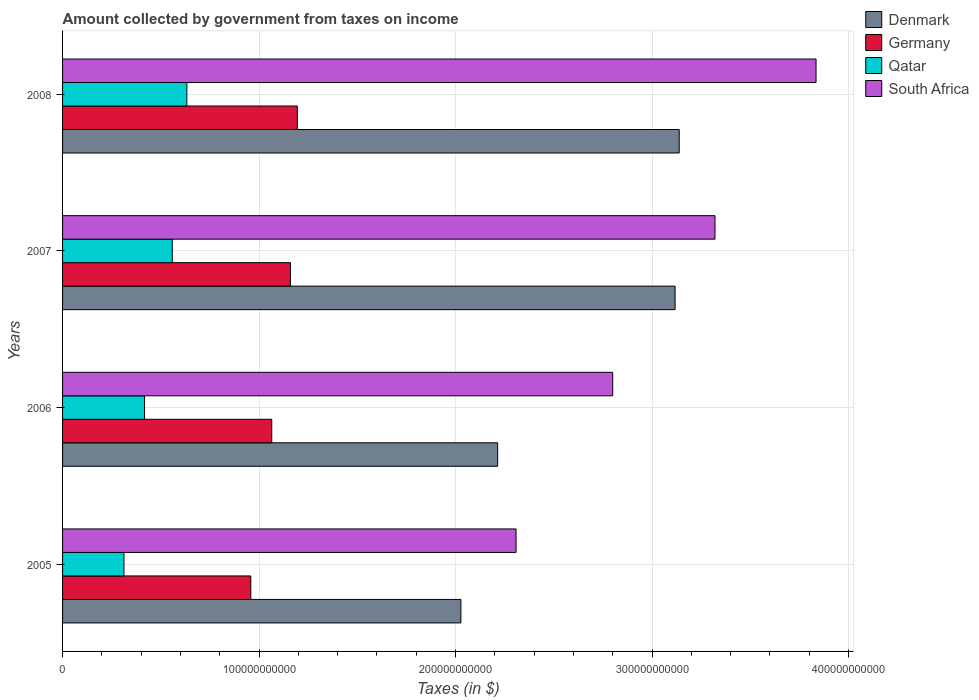How many different coloured bars are there?
Make the answer very short. 4. How many bars are there on the 3rd tick from the top?
Your answer should be very brief. 4. How many bars are there on the 2nd tick from the bottom?
Keep it short and to the point. 4. What is the label of the 1st group of bars from the top?
Offer a very short reply. 2008. In how many cases, is the number of bars for a given year not equal to the number of legend labels?
Offer a terse response. 0. What is the amount collected by government from taxes on income in Denmark in 2007?
Your answer should be very brief. 3.12e+11. Across all years, what is the maximum amount collected by government from taxes on income in Germany?
Provide a short and direct response. 1.19e+11. Across all years, what is the minimum amount collected by government from taxes on income in Denmark?
Your response must be concise. 2.03e+11. In which year was the amount collected by government from taxes on income in Germany maximum?
Offer a terse response. 2008. In which year was the amount collected by government from taxes on income in South Africa minimum?
Your response must be concise. 2005. What is the total amount collected by government from taxes on income in Germany in the graph?
Make the answer very short. 4.38e+11. What is the difference between the amount collected by government from taxes on income in South Africa in 2005 and that in 2006?
Provide a short and direct response. -4.92e+1. What is the difference between the amount collected by government from taxes on income in Germany in 2006 and the amount collected by government from taxes on income in Qatar in 2008?
Your answer should be very brief. 4.32e+1. What is the average amount collected by government from taxes on income in South Africa per year?
Give a very brief answer. 3.07e+11. In the year 2006, what is the difference between the amount collected by government from taxes on income in South Africa and amount collected by government from taxes on income in Germany?
Provide a succinct answer. 1.74e+11. In how many years, is the amount collected by government from taxes on income in South Africa greater than 240000000000 $?
Offer a terse response. 3. What is the ratio of the amount collected by government from taxes on income in Qatar in 2007 to that in 2008?
Your response must be concise. 0.88. Is the amount collected by government from taxes on income in Qatar in 2006 less than that in 2008?
Provide a short and direct response. Yes. Is the difference between the amount collected by government from taxes on income in South Africa in 2005 and 2008 greater than the difference between the amount collected by government from taxes on income in Germany in 2005 and 2008?
Your answer should be compact. No. What is the difference between the highest and the second highest amount collected by government from taxes on income in Germany?
Your response must be concise. 3.48e+09. What is the difference between the highest and the lowest amount collected by government from taxes on income in Denmark?
Your answer should be very brief. 1.11e+11. Is the sum of the amount collected by government from taxes on income in Germany in 2005 and 2007 greater than the maximum amount collected by government from taxes on income in Denmark across all years?
Offer a very short reply. No. What does the 2nd bar from the bottom in 2005 represents?
Your response must be concise. Germany. Are all the bars in the graph horizontal?
Provide a short and direct response. Yes. How many years are there in the graph?
Your response must be concise. 4. What is the difference between two consecutive major ticks on the X-axis?
Your answer should be compact. 1.00e+11. Where does the legend appear in the graph?
Keep it short and to the point. Top right. How many legend labels are there?
Your response must be concise. 4. How are the legend labels stacked?
Offer a very short reply. Vertical. What is the title of the graph?
Your answer should be very brief. Amount collected by government from taxes on income. What is the label or title of the X-axis?
Your answer should be very brief. Taxes (in $). What is the label or title of the Y-axis?
Offer a terse response. Years. What is the Taxes (in $) of Denmark in 2005?
Offer a terse response. 2.03e+11. What is the Taxes (in $) of Germany in 2005?
Give a very brief answer. 9.58e+1. What is the Taxes (in $) in Qatar in 2005?
Offer a very short reply. 3.12e+1. What is the Taxes (in $) in South Africa in 2005?
Give a very brief answer. 2.31e+11. What is the Taxes (in $) of Denmark in 2006?
Provide a succinct answer. 2.21e+11. What is the Taxes (in $) in Germany in 2006?
Make the answer very short. 1.06e+11. What is the Taxes (in $) of Qatar in 2006?
Keep it short and to the point. 4.17e+1. What is the Taxes (in $) in South Africa in 2006?
Offer a very short reply. 2.80e+11. What is the Taxes (in $) of Denmark in 2007?
Provide a short and direct response. 3.12e+11. What is the Taxes (in $) of Germany in 2007?
Ensure brevity in your answer.  1.16e+11. What is the Taxes (in $) of Qatar in 2007?
Offer a very short reply. 5.58e+1. What is the Taxes (in $) of South Africa in 2007?
Offer a very short reply. 3.32e+11. What is the Taxes (in $) in Denmark in 2008?
Offer a very short reply. 3.14e+11. What is the Taxes (in $) of Germany in 2008?
Offer a terse response. 1.19e+11. What is the Taxes (in $) in Qatar in 2008?
Ensure brevity in your answer.  6.33e+1. What is the Taxes (in $) of South Africa in 2008?
Ensure brevity in your answer.  3.83e+11. Across all years, what is the maximum Taxes (in $) in Denmark?
Offer a terse response. 3.14e+11. Across all years, what is the maximum Taxes (in $) in Germany?
Provide a succinct answer. 1.19e+11. Across all years, what is the maximum Taxes (in $) of Qatar?
Provide a short and direct response. 6.33e+1. Across all years, what is the maximum Taxes (in $) of South Africa?
Offer a terse response. 3.83e+11. Across all years, what is the minimum Taxes (in $) in Denmark?
Your response must be concise. 2.03e+11. Across all years, what is the minimum Taxes (in $) of Germany?
Provide a succinct answer. 9.58e+1. Across all years, what is the minimum Taxes (in $) in Qatar?
Offer a terse response. 3.12e+1. Across all years, what is the minimum Taxes (in $) in South Africa?
Keep it short and to the point. 2.31e+11. What is the total Taxes (in $) of Denmark in the graph?
Offer a terse response. 1.05e+12. What is the total Taxes (in $) of Germany in the graph?
Your response must be concise. 4.38e+11. What is the total Taxes (in $) of Qatar in the graph?
Offer a very short reply. 1.92e+11. What is the total Taxes (in $) in South Africa in the graph?
Your answer should be compact. 1.23e+12. What is the difference between the Taxes (in $) of Denmark in 2005 and that in 2006?
Give a very brief answer. -1.87e+1. What is the difference between the Taxes (in $) in Germany in 2005 and that in 2006?
Your answer should be compact. -1.07e+1. What is the difference between the Taxes (in $) in Qatar in 2005 and that in 2006?
Your response must be concise. -1.05e+1. What is the difference between the Taxes (in $) of South Africa in 2005 and that in 2006?
Provide a short and direct response. -4.92e+1. What is the difference between the Taxes (in $) in Denmark in 2005 and that in 2007?
Offer a very short reply. -1.09e+11. What is the difference between the Taxes (in $) of Germany in 2005 and that in 2007?
Provide a succinct answer. -2.02e+1. What is the difference between the Taxes (in $) of Qatar in 2005 and that in 2007?
Provide a short and direct response. -2.46e+1. What is the difference between the Taxes (in $) in South Africa in 2005 and that in 2007?
Your response must be concise. -1.01e+11. What is the difference between the Taxes (in $) in Denmark in 2005 and that in 2008?
Offer a very short reply. -1.11e+11. What is the difference between the Taxes (in $) in Germany in 2005 and that in 2008?
Keep it short and to the point. -2.37e+1. What is the difference between the Taxes (in $) of Qatar in 2005 and that in 2008?
Provide a short and direct response. -3.20e+1. What is the difference between the Taxes (in $) of South Africa in 2005 and that in 2008?
Provide a short and direct response. -1.53e+11. What is the difference between the Taxes (in $) in Denmark in 2006 and that in 2007?
Your answer should be compact. -9.03e+1. What is the difference between the Taxes (in $) of Germany in 2006 and that in 2007?
Give a very brief answer. -9.53e+09. What is the difference between the Taxes (in $) of Qatar in 2006 and that in 2007?
Your answer should be compact. -1.41e+1. What is the difference between the Taxes (in $) in South Africa in 2006 and that in 2007?
Offer a very short reply. -5.21e+1. What is the difference between the Taxes (in $) of Denmark in 2006 and that in 2008?
Give a very brief answer. -9.24e+1. What is the difference between the Taxes (in $) of Germany in 2006 and that in 2008?
Your answer should be compact. -1.30e+1. What is the difference between the Taxes (in $) of Qatar in 2006 and that in 2008?
Your response must be concise. -2.15e+1. What is the difference between the Taxes (in $) in South Africa in 2006 and that in 2008?
Keep it short and to the point. -1.03e+11. What is the difference between the Taxes (in $) of Denmark in 2007 and that in 2008?
Make the answer very short. -2.10e+09. What is the difference between the Taxes (in $) of Germany in 2007 and that in 2008?
Offer a very short reply. -3.48e+09. What is the difference between the Taxes (in $) of Qatar in 2007 and that in 2008?
Your answer should be very brief. -7.43e+09. What is the difference between the Taxes (in $) of South Africa in 2007 and that in 2008?
Your answer should be very brief. -5.14e+1. What is the difference between the Taxes (in $) in Denmark in 2005 and the Taxes (in $) in Germany in 2006?
Your answer should be compact. 9.63e+1. What is the difference between the Taxes (in $) of Denmark in 2005 and the Taxes (in $) of Qatar in 2006?
Make the answer very short. 1.61e+11. What is the difference between the Taxes (in $) of Denmark in 2005 and the Taxes (in $) of South Africa in 2006?
Your response must be concise. -7.73e+1. What is the difference between the Taxes (in $) of Germany in 2005 and the Taxes (in $) of Qatar in 2006?
Your response must be concise. 5.41e+1. What is the difference between the Taxes (in $) in Germany in 2005 and the Taxes (in $) in South Africa in 2006?
Provide a succinct answer. -1.84e+11. What is the difference between the Taxes (in $) of Qatar in 2005 and the Taxes (in $) of South Africa in 2006?
Ensure brevity in your answer.  -2.49e+11. What is the difference between the Taxes (in $) of Denmark in 2005 and the Taxes (in $) of Germany in 2007?
Your answer should be very brief. 8.67e+1. What is the difference between the Taxes (in $) of Denmark in 2005 and the Taxes (in $) of Qatar in 2007?
Keep it short and to the point. 1.47e+11. What is the difference between the Taxes (in $) of Denmark in 2005 and the Taxes (in $) of South Africa in 2007?
Keep it short and to the point. -1.29e+11. What is the difference between the Taxes (in $) of Germany in 2005 and the Taxes (in $) of Qatar in 2007?
Offer a very short reply. 4.00e+1. What is the difference between the Taxes (in $) of Germany in 2005 and the Taxes (in $) of South Africa in 2007?
Keep it short and to the point. -2.36e+11. What is the difference between the Taxes (in $) of Qatar in 2005 and the Taxes (in $) of South Africa in 2007?
Provide a succinct answer. -3.01e+11. What is the difference between the Taxes (in $) in Denmark in 2005 and the Taxes (in $) in Germany in 2008?
Your answer should be very brief. 8.33e+1. What is the difference between the Taxes (in $) of Denmark in 2005 and the Taxes (in $) of Qatar in 2008?
Your answer should be very brief. 1.39e+11. What is the difference between the Taxes (in $) in Denmark in 2005 and the Taxes (in $) in South Africa in 2008?
Keep it short and to the point. -1.81e+11. What is the difference between the Taxes (in $) of Germany in 2005 and the Taxes (in $) of Qatar in 2008?
Give a very brief answer. 3.25e+1. What is the difference between the Taxes (in $) of Germany in 2005 and the Taxes (in $) of South Africa in 2008?
Your answer should be compact. -2.88e+11. What is the difference between the Taxes (in $) in Qatar in 2005 and the Taxes (in $) in South Africa in 2008?
Offer a very short reply. -3.52e+11. What is the difference between the Taxes (in $) in Denmark in 2006 and the Taxes (in $) in Germany in 2007?
Give a very brief answer. 1.05e+11. What is the difference between the Taxes (in $) in Denmark in 2006 and the Taxes (in $) in Qatar in 2007?
Your response must be concise. 1.66e+11. What is the difference between the Taxes (in $) of Denmark in 2006 and the Taxes (in $) of South Africa in 2007?
Make the answer very short. -1.11e+11. What is the difference between the Taxes (in $) of Germany in 2006 and the Taxes (in $) of Qatar in 2007?
Provide a short and direct response. 5.06e+1. What is the difference between the Taxes (in $) of Germany in 2006 and the Taxes (in $) of South Africa in 2007?
Ensure brevity in your answer.  -2.26e+11. What is the difference between the Taxes (in $) in Qatar in 2006 and the Taxes (in $) in South Africa in 2007?
Provide a short and direct response. -2.90e+11. What is the difference between the Taxes (in $) of Denmark in 2006 and the Taxes (in $) of Germany in 2008?
Provide a succinct answer. 1.02e+11. What is the difference between the Taxes (in $) of Denmark in 2006 and the Taxes (in $) of Qatar in 2008?
Your answer should be compact. 1.58e+11. What is the difference between the Taxes (in $) of Denmark in 2006 and the Taxes (in $) of South Africa in 2008?
Your response must be concise. -1.62e+11. What is the difference between the Taxes (in $) in Germany in 2006 and the Taxes (in $) in Qatar in 2008?
Keep it short and to the point. 4.32e+1. What is the difference between the Taxes (in $) of Germany in 2006 and the Taxes (in $) of South Africa in 2008?
Give a very brief answer. -2.77e+11. What is the difference between the Taxes (in $) of Qatar in 2006 and the Taxes (in $) of South Africa in 2008?
Give a very brief answer. -3.42e+11. What is the difference between the Taxes (in $) of Denmark in 2007 and the Taxes (in $) of Germany in 2008?
Your answer should be compact. 1.92e+11. What is the difference between the Taxes (in $) in Denmark in 2007 and the Taxes (in $) in Qatar in 2008?
Your answer should be very brief. 2.48e+11. What is the difference between the Taxes (in $) in Denmark in 2007 and the Taxes (in $) in South Africa in 2008?
Give a very brief answer. -7.17e+1. What is the difference between the Taxes (in $) of Germany in 2007 and the Taxes (in $) of Qatar in 2008?
Offer a terse response. 5.27e+1. What is the difference between the Taxes (in $) in Germany in 2007 and the Taxes (in $) in South Africa in 2008?
Your response must be concise. -2.67e+11. What is the difference between the Taxes (in $) of Qatar in 2007 and the Taxes (in $) of South Africa in 2008?
Give a very brief answer. -3.28e+11. What is the average Taxes (in $) in Denmark per year?
Your answer should be very brief. 2.62e+11. What is the average Taxes (in $) of Germany per year?
Offer a very short reply. 1.09e+11. What is the average Taxes (in $) in Qatar per year?
Ensure brevity in your answer.  4.80e+1. What is the average Taxes (in $) of South Africa per year?
Keep it short and to the point. 3.07e+11. In the year 2005, what is the difference between the Taxes (in $) in Denmark and Taxes (in $) in Germany?
Offer a terse response. 1.07e+11. In the year 2005, what is the difference between the Taxes (in $) of Denmark and Taxes (in $) of Qatar?
Provide a short and direct response. 1.71e+11. In the year 2005, what is the difference between the Taxes (in $) in Denmark and Taxes (in $) in South Africa?
Keep it short and to the point. -2.81e+1. In the year 2005, what is the difference between the Taxes (in $) of Germany and Taxes (in $) of Qatar?
Provide a succinct answer. 6.46e+1. In the year 2005, what is the difference between the Taxes (in $) in Germany and Taxes (in $) in South Africa?
Offer a terse response. -1.35e+11. In the year 2005, what is the difference between the Taxes (in $) in Qatar and Taxes (in $) in South Africa?
Offer a very short reply. -2.00e+11. In the year 2006, what is the difference between the Taxes (in $) in Denmark and Taxes (in $) in Germany?
Your answer should be compact. 1.15e+11. In the year 2006, what is the difference between the Taxes (in $) in Denmark and Taxes (in $) in Qatar?
Provide a succinct answer. 1.80e+11. In the year 2006, what is the difference between the Taxes (in $) of Denmark and Taxes (in $) of South Africa?
Ensure brevity in your answer.  -5.86e+1. In the year 2006, what is the difference between the Taxes (in $) of Germany and Taxes (in $) of Qatar?
Your response must be concise. 6.47e+1. In the year 2006, what is the difference between the Taxes (in $) of Germany and Taxes (in $) of South Africa?
Offer a terse response. -1.74e+11. In the year 2006, what is the difference between the Taxes (in $) of Qatar and Taxes (in $) of South Africa?
Provide a short and direct response. -2.38e+11. In the year 2007, what is the difference between the Taxes (in $) of Denmark and Taxes (in $) of Germany?
Offer a very short reply. 1.96e+11. In the year 2007, what is the difference between the Taxes (in $) in Denmark and Taxes (in $) in Qatar?
Make the answer very short. 2.56e+11. In the year 2007, what is the difference between the Taxes (in $) of Denmark and Taxes (in $) of South Africa?
Offer a very short reply. -2.03e+1. In the year 2007, what is the difference between the Taxes (in $) of Germany and Taxes (in $) of Qatar?
Offer a very short reply. 6.02e+1. In the year 2007, what is the difference between the Taxes (in $) of Germany and Taxes (in $) of South Africa?
Provide a succinct answer. -2.16e+11. In the year 2007, what is the difference between the Taxes (in $) in Qatar and Taxes (in $) in South Africa?
Your answer should be compact. -2.76e+11. In the year 2008, what is the difference between the Taxes (in $) in Denmark and Taxes (in $) in Germany?
Offer a very short reply. 1.94e+11. In the year 2008, what is the difference between the Taxes (in $) in Denmark and Taxes (in $) in Qatar?
Your answer should be very brief. 2.51e+11. In the year 2008, what is the difference between the Taxes (in $) of Denmark and Taxes (in $) of South Africa?
Keep it short and to the point. -6.96e+1. In the year 2008, what is the difference between the Taxes (in $) of Germany and Taxes (in $) of Qatar?
Offer a terse response. 5.62e+1. In the year 2008, what is the difference between the Taxes (in $) in Germany and Taxes (in $) in South Africa?
Your answer should be very brief. -2.64e+11. In the year 2008, what is the difference between the Taxes (in $) of Qatar and Taxes (in $) of South Africa?
Offer a very short reply. -3.20e+11. What is the ratio of the Taxes (in $) of Denmark in 2005 to that in 2006?
Offer a very short reply. 0.92. What is the ratio of the Taxes (in $) in Germany in 2005 to that in 2006?
Provide a short and direct response. 0.9. What is the ratio of the Taxes (in $) in Qatar in 2005 to that in 2006?
Offer a terse response. 0.75. What is the ratio of the Taxes (in $) in South Africa in 2005 to that in 2006?
Make the answer very short. 0.82. What is the ratio of the Taxes (in $) in Denmark in 2005 to that in 2007?
Offer a terse response. 0.65. What is the ratio of the Taxes (in $) of Germany in 2005 to that in 2007?
Your answer should be very brief. 0.83. What is the ratio of the Taxes (in $) in Qatar in 2005 to that in 2007?
Offer a very short reply. 0.56. What is the ratio of the Taxes (in $) of South Africa in 2005 to that in 2007?
Your answer should be compact. 0.7. What is the ratio of the Taxes (in $) in Denmark in 2005 to that in 2008?
Keep it short and to the point. 0.65. What is the ratio of the Taxes (in $) of Germany in 2005 to that in 2008?
Your answer should be very brief. 0.8. What is the ratio of the Taxes (in $) in Qatar in 2005 to that in 2008?
Offer a very short reply. 0.49. What is the ratio of the Taxes (in $) of South Africa in 2005 to that in 2008?
Your answer should be very brief. 0.6. What is the ratio of the Taxes (in $) in Denmark in 2006 to that in 2007?
Your response must be concise. 0.71. What is the ratio of the Taxes (in $) of Germany in 2006 to that in 2007?
Make the answer very short. 0.92. What is the ratio of the Taxes (in $) in Qatar in 2006 to that in 2007?
Offer a terse response. 0.75. What is the ratio of the Taxes (in $) of South Africa in 2006 to that in 2007?
Offer a very short reply. 0.84. What is the ratio of the Taxes (in $) of Denmark in 2006 to that in 2008?
Your answer should be very brief. 0.71. What is the ratio of the Taxes (in $) of Germany in 2006 to that in 2008?
Offer a very short reply. 0.89. What is the ratio of the Taxes (in $) in Qatar in 2006 to that in 2008?
Your answer should be compact. 0.66. What is the ratio of the Taxes (in $) of South Africa in 2006 to that in 2008?
Offer a terse response. 0.73. What is the ratio of the Taxes (in $) of Denmark in 2007 to that in 2008?
Your answer should be compact. 0.99. What is the ratio of the Taxes (in $) in Germany in 2007 to that in 2008?
Your answer should be compact. 0.97. What is the ratio of the Taxes (in $) of Qatar in 2007 to that in 2008?
Give a very brief answer. 0.88. What is the ratio of the Taxes (in $) in South Africa in 2007 to that in 2008?
Offer a terse response. 0.87. What is the difference between the highest and the second highest Taxes (in $) of Denmark?
Give a very brief answer. 2.10e+09. What is the difference between the highest and the second highest Taxes (in $) in Germany?
Your answer should be compact. 3.48e+09. What is the difference between the highest and the second highest Taxes (in $) in Qatar?
Keep it short and to the point. 7.43e+09. What is the difference between the highest and the second highest Taxes (in $) of South Africa?
Keep it short and to the point. 5.14e+1. What is the difference between the highest and the lowest Taxes (in $) in Denmark?
Give a very brief answer. 1.11e+11. What is the difference between the highest and the lowest Taxes (in $) of Germany?
Your answer should be very brief. 2.37e+1. What is the difference between the highest and the lowest Taxes (in $) in Qatar?
Offer a very short reply. 3.20e+1. What is the difference between the highest and the lowest Taxes (in $) of South Africa?
Provide a short and direct response. 1.53e+11. 